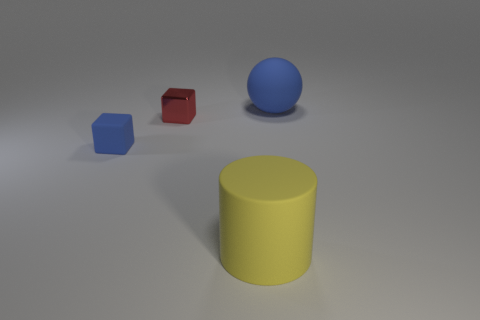Are there any blue objects of the same size as the ball?
Your answer should be very brief. No. What is the color of the other thing that is the same shape as the tiny blue thing?
Provide a succinct answer. Red. There is a thing behind the red object; is its size the same as the object that is in front of the rubber cube?
Offer a very short reply. Yes. Is there another red thing that has the same shape as the small metal object?
Your answer should be compact. No. Are there the same number of small metallic things in front of the large yellow matte object and purple cylinders?
Your answer should be very brief. Yes. Is the size of the blue sphere the same as the blue object that is to the left of the big cylinder?
Offer a very short reply. No. How many large yellow objects have the same material as the small blue block?
Make the answer very short. 1. Is the size of the matte block the same as the cylinder?
Give a very brief answer. No. Is there any other thing of the same color as the cylinder?
Offer a very short reply. No. What is the shape of the object that is to the left of the big blue object and on the right side of the metal block?
Ensure brevity in your answer.  Cylinder. 